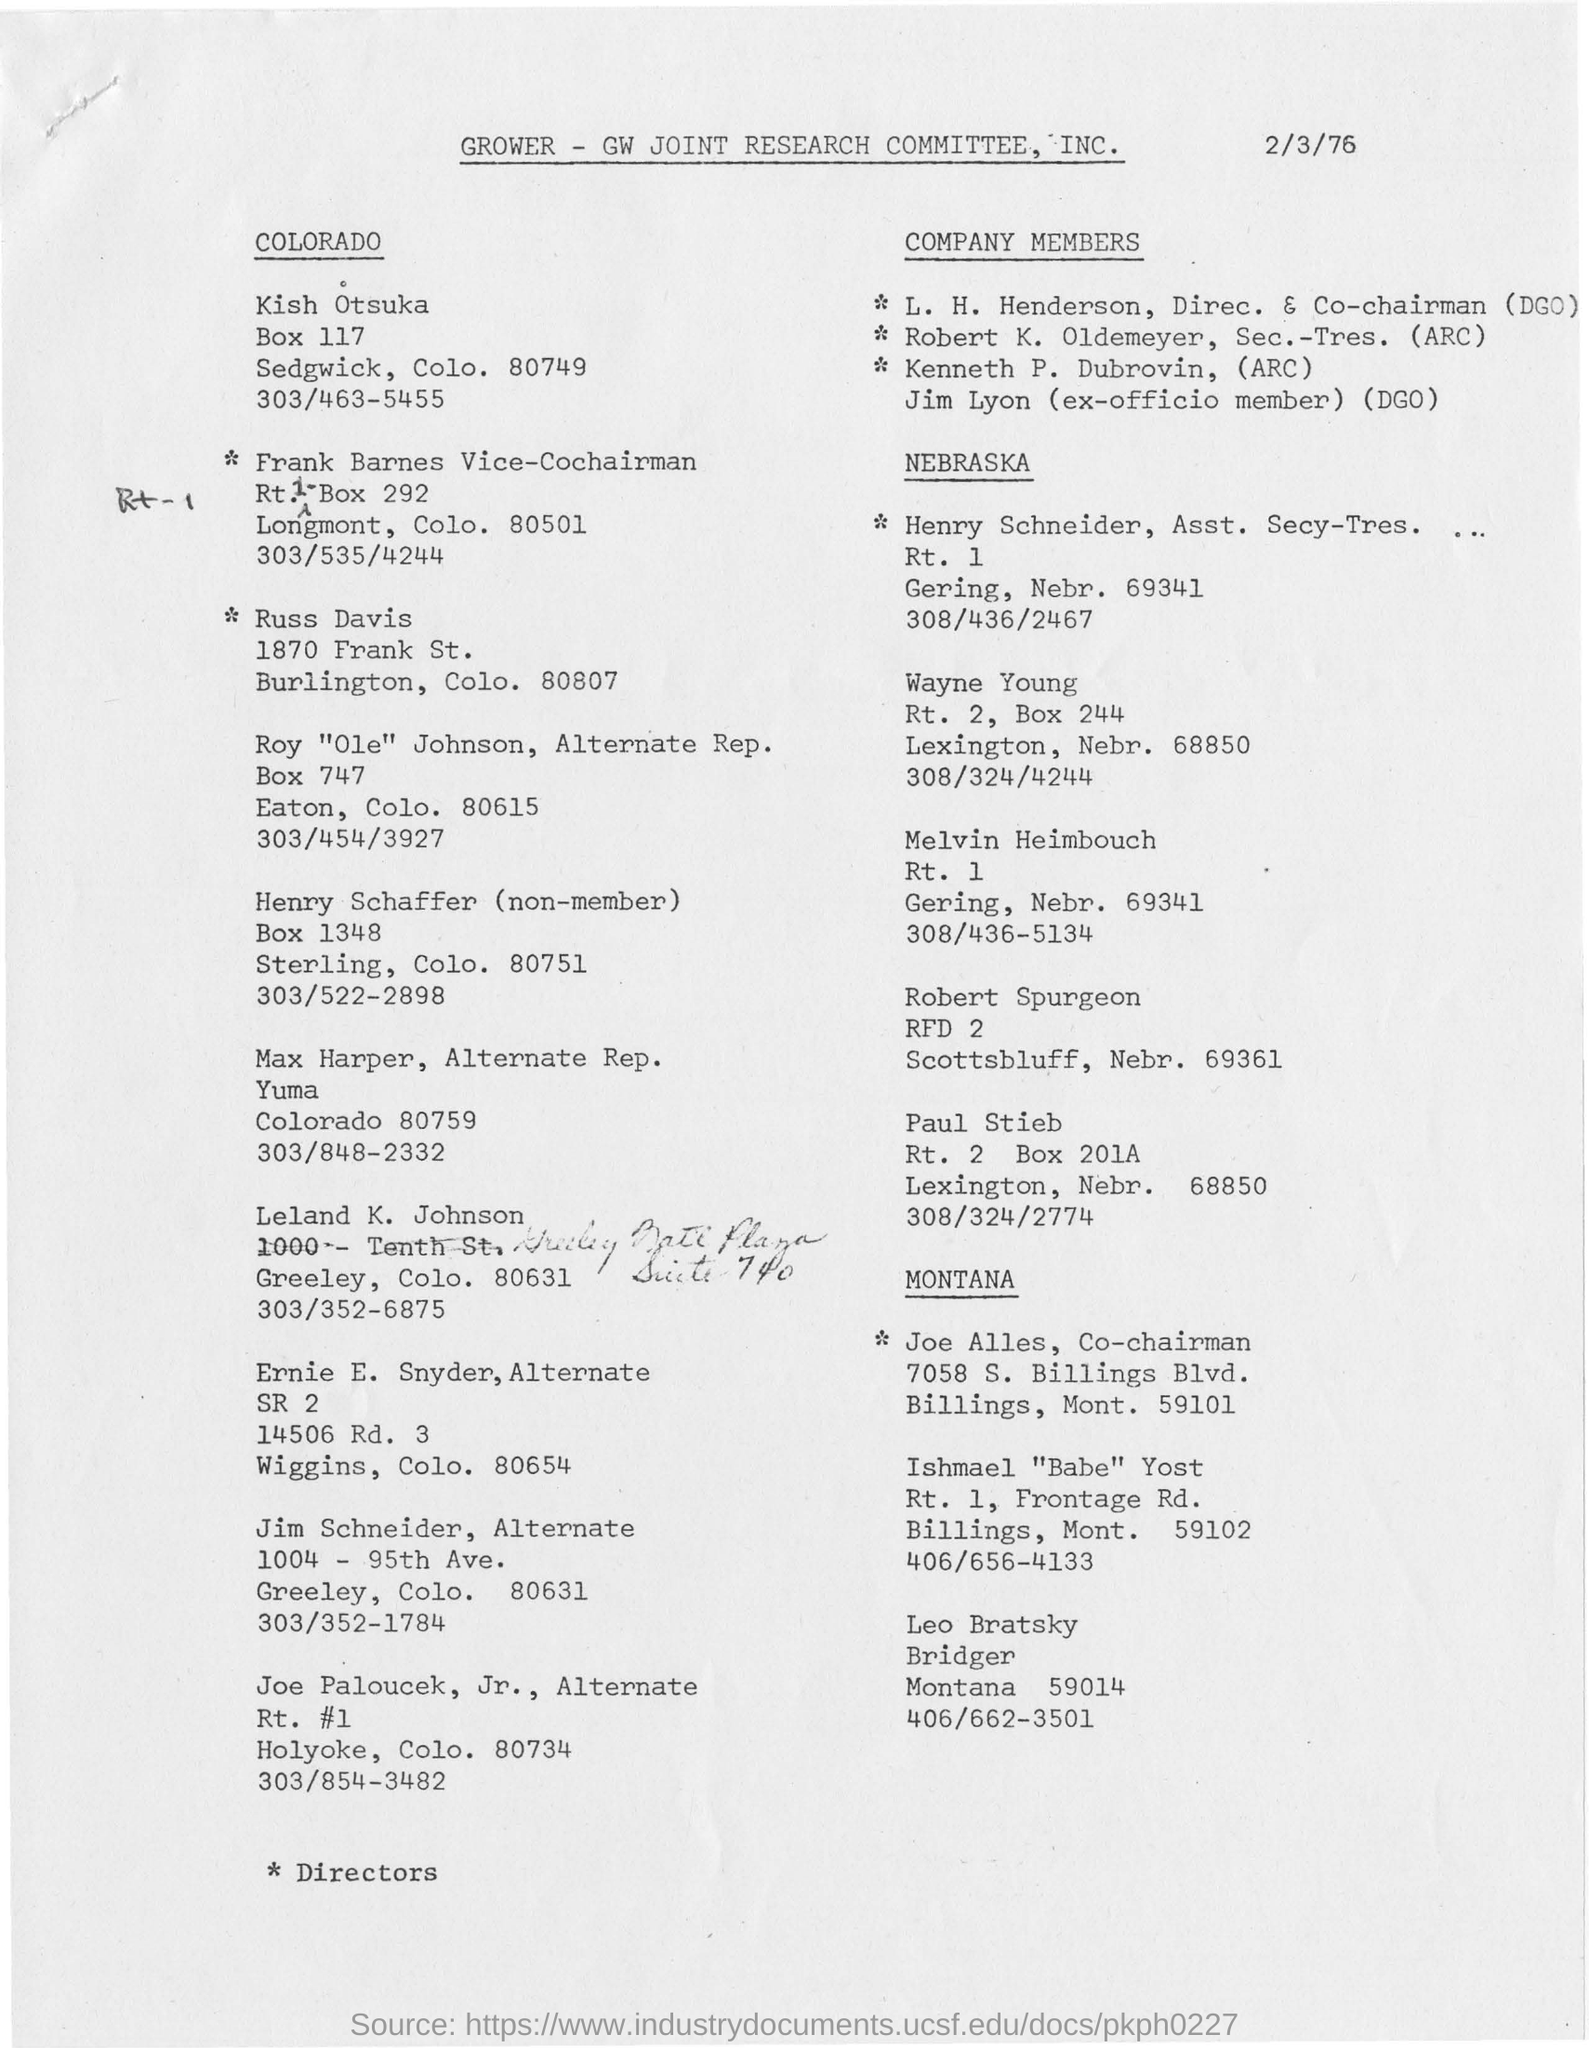What is the date mentioned in this document?
Keep it short and to the point. 2/3/76. What is the document about?
Keep it short and to the point. GROWER-GW JOINT RESEARCH COMMITTEE, INC. What is the designation of L. H. Henderson?
Your answer should be compact. Direc. & Co-chairman (DGO). Who is the ex-officio member(DGO) ?
Give a very brief answer. Jim Lyon. 